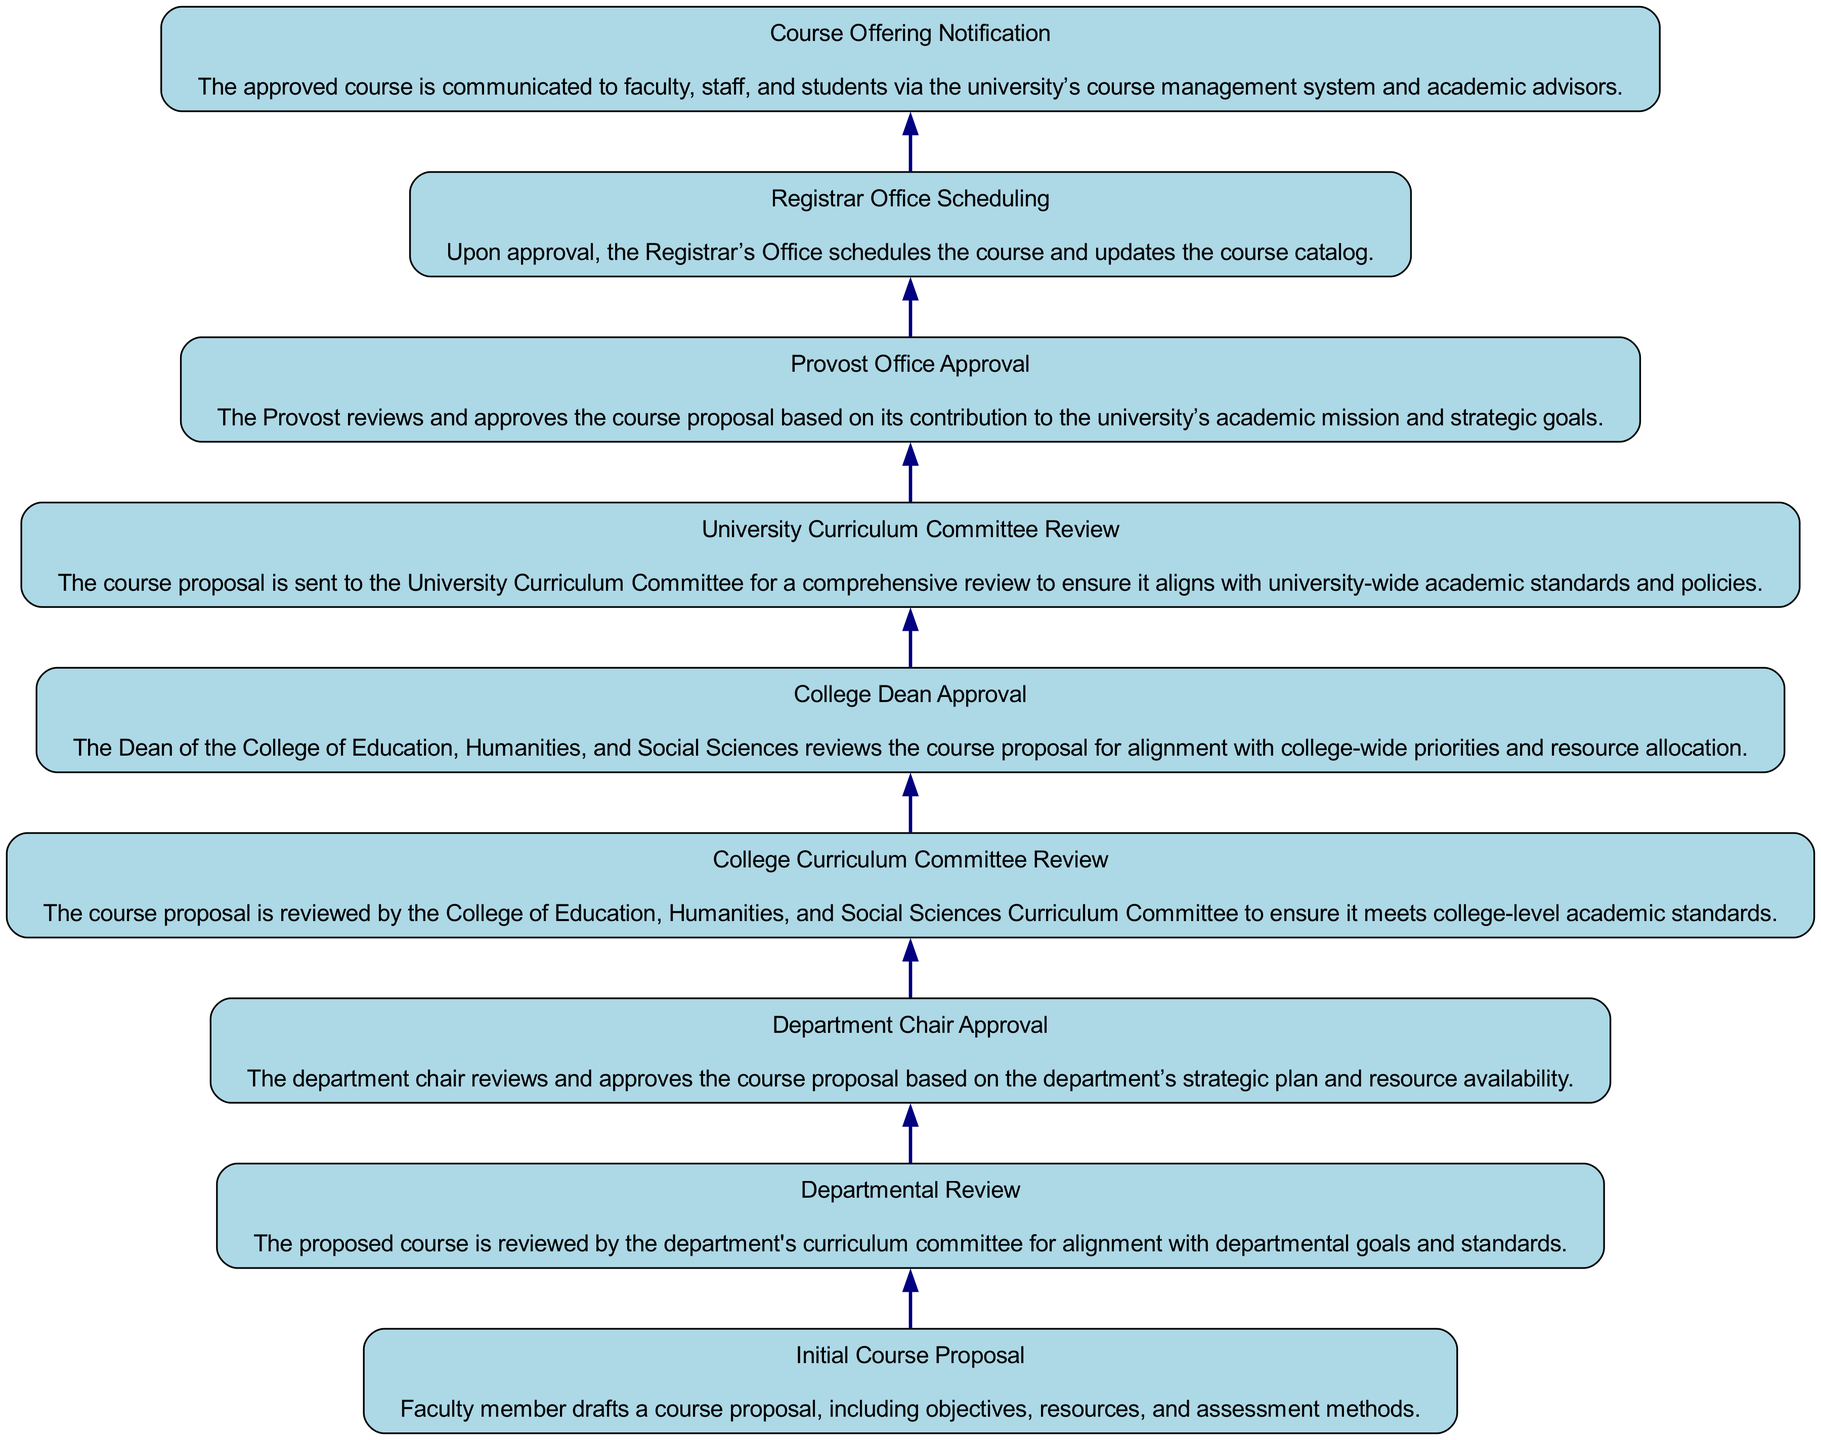What is the first step in the course planning process? The first step is the "Initial Course Proposal," where a faculty member drafts a course proposal including objectives, resources, and assessment methods.
Answer: Initial Course Proposal How many nodes are present in the diagram? The diagram includes 9 nodes, each representing a different step in the course planning and approval process, from the "Initial Course Proposal" to "Course Offering Notification."
Answer: 9 What comes after the "Department Chair Approval"? The step that follows "Department Chair Approval" is the "College Curriculum Committee Review," indicating that the course proposal must undergo review at the college level after departmental approval.
Answer: College Curriculum Committee Review Which node is the last step in the process? The final node in the process is "Course Offering Notification," signifying that once the course is approved and scheduled, it will be communicated to faculty, staff, and students.
Answer: Course Offering Notification What is the relationship between the "University Curriculum Committee Review" and the "Provost Office Approval"? The "University Curriculum Committee Review" must happen before the "Provost Office Approval," meaning the proposal needs to be reviewed by the University Curriculum Committee prior to seeking approval from the Provost.
Answer: Sequential relationship How many approvals are granted from the "Initial Course Proposal" to the "Provost Office Approval"? There are three approvals in this flow: first from the "Department Chair," then from the "College Dean," and lastly from the "Provost," making a total of three approval steps.
Answer: Three approvals What does the "Registrar Office Scheduling" node signify? This node indicates that once the course proposal has been approved, the Registrar's Office will take the initiative to schedule the course and update the course catalog accordingly.
Answer: Scheduling and catalog update What is the primary function of the "College Dean Approval"? The primary function of the "College Dean Approval" is to review the course proposal for alignment with college-wide priorities and make decisions about resource allocation.
Answer: Alignment and resource allocation Which nodes indicate an approval process in the diagram? The nodes that represent an approval process include "Department Chair Approval," "College Dean Approval," "University Curriculum Committee Review," and "Provost Office Approval," all of which involve reviewing and approving the course proposal.
Answer: Department Chair Approval, College Dean Approval, University Curriculum Committee Review, Provost Office Approval 